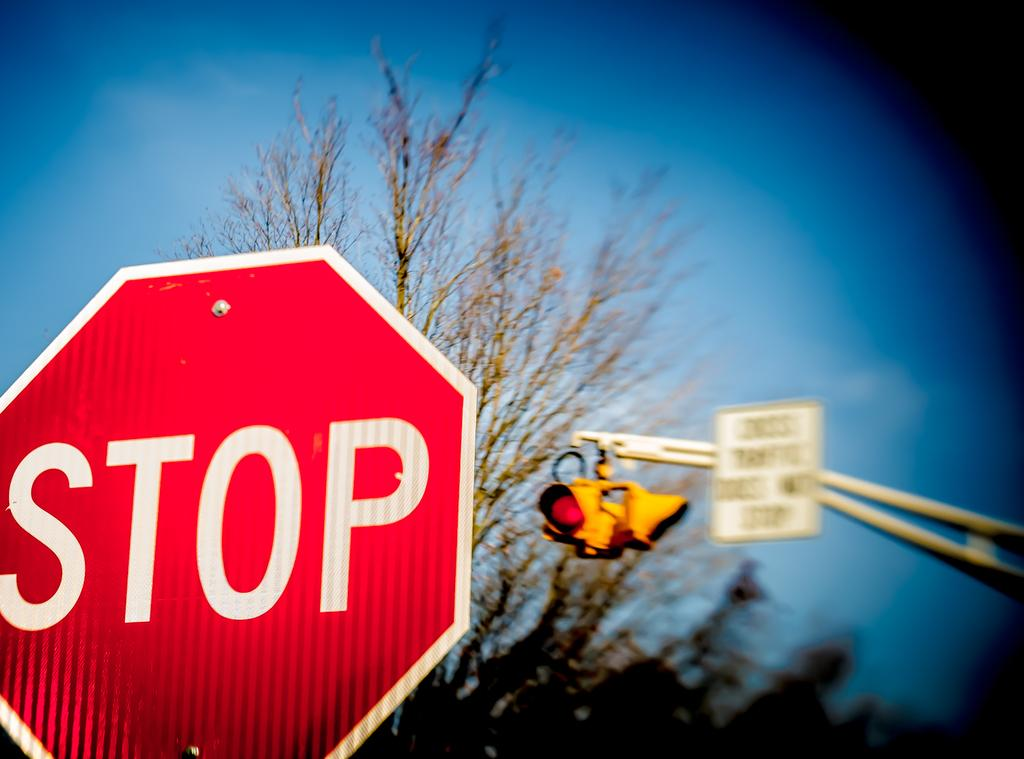<image>
Create a compact narrative representing the image presented. A red stop sign sits in front of a traffic light. 